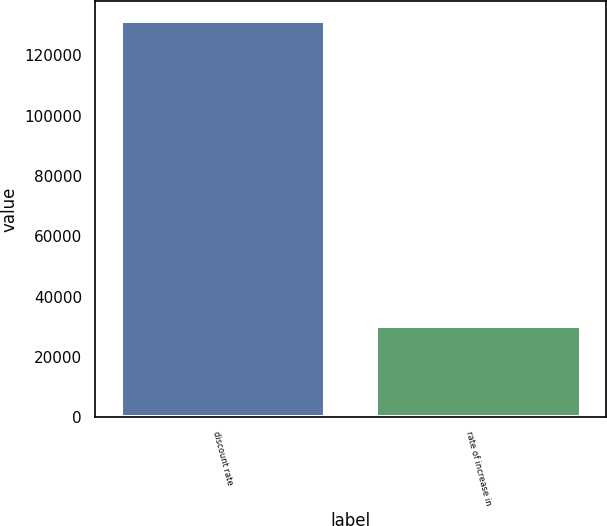<chart> <loc_0><loc_0><loc_500><loc_500><bar_chart><fcel>discount rate<fcel>rate of increase in<nl><fcel>131414<fcel>30374<nl></chart> 